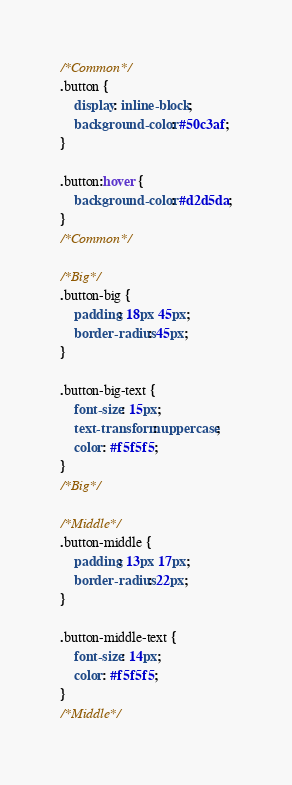<code> <loc_0><loc_0><loc_500><loc_500><_CSS_>/*Common*/
.button {
    display: inline-block;
    background-color: #50c3af;
}

.button:hover {
    background-color: #d2d5da;
}
/*Common*/

/*Big*/
.button-big {
    padding: 18px 45px;
    border-radius: 45px;
}

.button-big-text {
    font-size: 15px;
    text-transform: uppercase;
    color: #f5f5f5;
}
/*Big*/

/*Middle*/
.button-middle {
    padding: 13px 17px;
    border-radius: 22px;
}

.button-middle-text {
    font-size: 14px;
    color: #f5f5f5;
}
/*Middle*/
</code> 